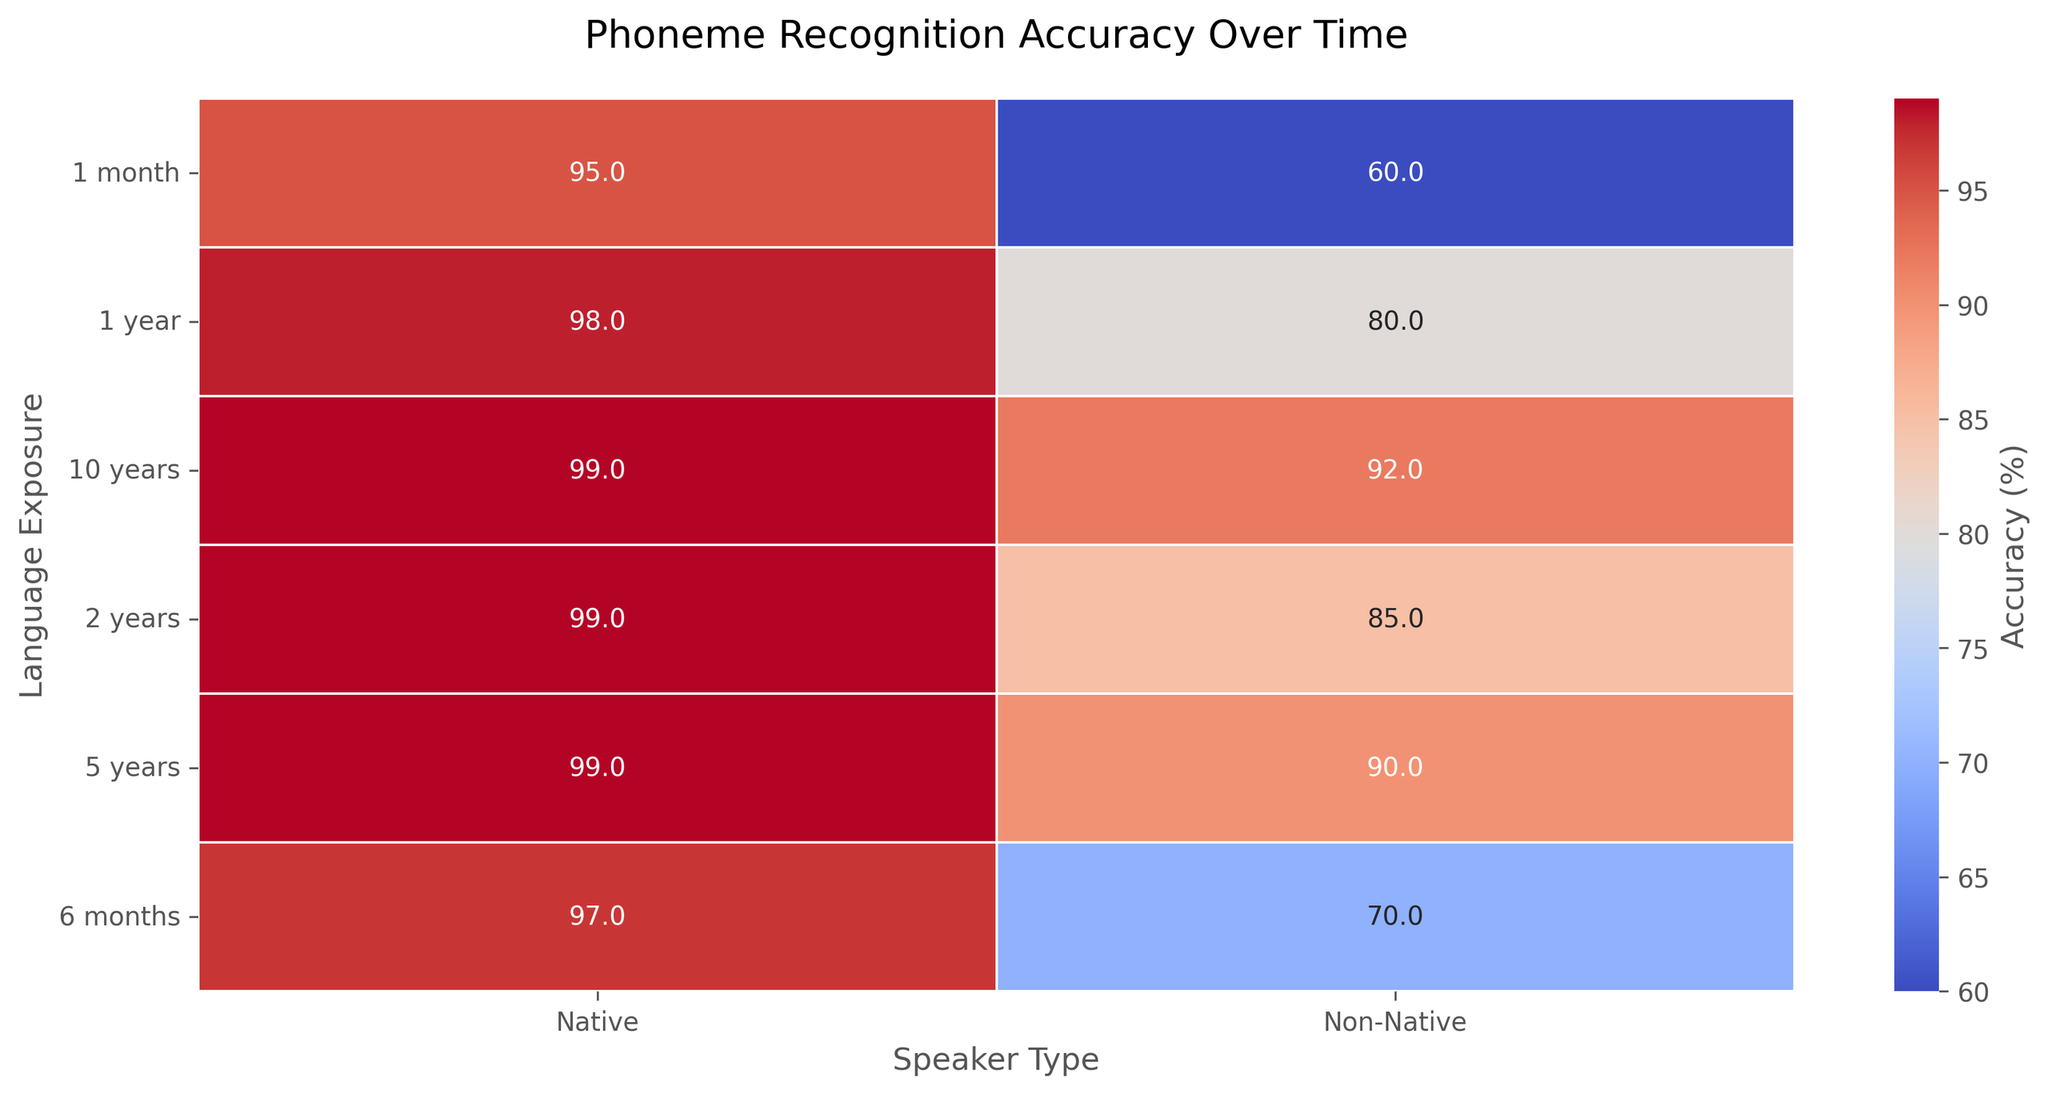What is the phoneme recognition accuracy for native speakers after 2 years of language exposure? Look at the value in the heatmap where "Language Exposure" is 2 years and "Speaker Type" is Native.
Answer: 99 How does the phoneme recognition accuracy change for non-native speakers from 1 month to 1 year? Locate the values in the heatmap for "Non-Native" speakers under the "Language Exposure" intervals of 1 month and 1 year, then calculate the difference. From 1 month to 1 year, the accuracy increases from 60 to 80.
Answer: Increases by 20 Which speaker type has higher phoneme recognition accuracy after 6 months of exposure? Compare the accuracy values for "Native" and "Non-Native" speakers under the 6 months "Language Exposure" interval.
Answer: Native What is the overall trend in phoneme recognition accuracy for non-native speakers over time? Observe the changes in the heatmap values for “Non-Native” speakers across different "Language Exposure" intervals. The accuracy increases progressively.
Answer: Increases What is the average phoneme recognition accuracy for native speakers over all time periods? Extract the accuracy values for "Native" speakers from all "Language Exposure" intervals and calculate their average: (95 + 97 + 98 + 99 + 99 + 99) / 6.
Answer: 97.8 By how much does phoneme recognition accuracy improve for non-native speakers between 2 years and 10 years of exposure? Look at the values for "Non-Native" speakers at the "Language Exposure" intervals of 2 years and 10 years, then calculate the difference. (92 - 85)
Answer: Increases by 7 Which period shows the highest improvement in accuracy for non-native speakers? Calculate the difference between successive time periods for "Non-Native" speakers and determine the largest increase. The highest increase is between 1 month and 1 year (80 - 60 = 20).
Answer: 1 month to 1 year What is the color indicating the highest phoneme recognition accuracy on the heatmap? Observe the color associated with the highest values on the heatmap, which represent accuracy percentages close to 99%.
Answer: Darker red Are there any instances where non-native speakers’ recognition accuracy is higher than 90%? Look for accuracy values greater than 90% in the "Non-Native" section of the heatmap. Note that "10 years" has an accuracy of 92%.
Answer: Yes (10 years) What is the difference in phoneme recognition accuracy between native and non-native speakers after 5 years? Calculate the difference between the accuracy values of "Native" and "Non-Native" speakers at the "5 years" interval. (99 - 90).
Answer: 9 